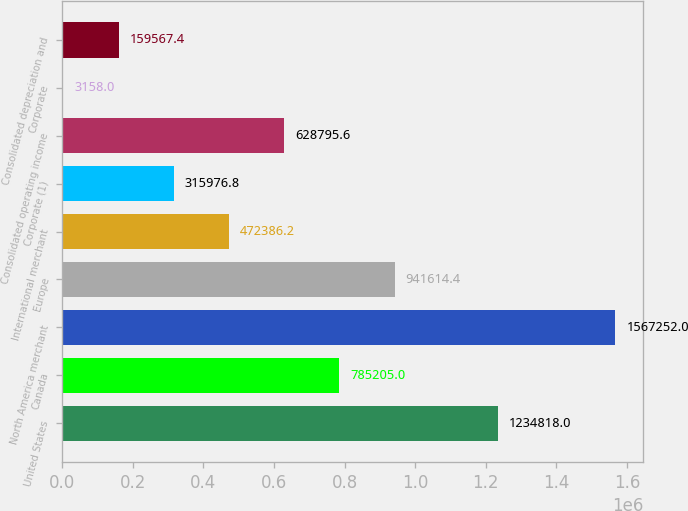Convert chart to OTSL. <chart><loc_0><loc_0><loc_500><loc_500><bar_chart><fcel>United States<fcel>Canada<fcel>North America merchant<fcel>Europe<fcel>International merchant<fcel>Corporate (1)<fcel>Consolidated operating income<fcel>Corporate<fcel>Consolidated depreciation and<nl><fcel>1.23482e+06<fcel>785205<fcel>1.56725e+06<fcel>941614<fcel>472386<fcel>315977<fcel>628796<fcel>3158<fcel>159567<nl></chart> 